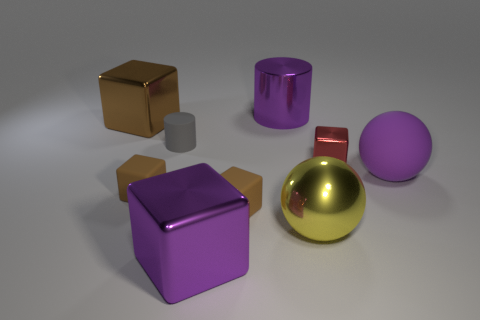Add 1 tiny gray cylinders. How many objects exist? 10 Subtract all small cubes. How many cubes are left? 2 Subtract 1 cubes. How many cubes are left? 4 Add 5 large purple metal cylinders. How many large purple metal cylinders exist? 6 Subtract all brown cubes. How many cubes are left? 2 Subtract 0 red cylinders. How many objects are left? 9 Subtract all spheres. How many objects are left? 7 Subtract all red cylinders. Subtract all red balls. How many cylinders are left? 2 Subtract all brown spheres. How many yellow cylinders are left? 0 Subtract all rubber cubes. Subtract all tiny red metallic blocks. How many objects are left? 6 